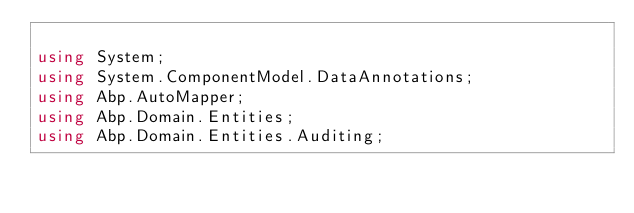<code> <loc_0><loc_0><loc_500><loc_500><_C#_>
using System;
using System.ComponentModel.DataAnnotations;
using Abp.AutoMapper;
using Abp.Domain.Entities;
using Abp.Domain.Entities.Auditing;</code> 